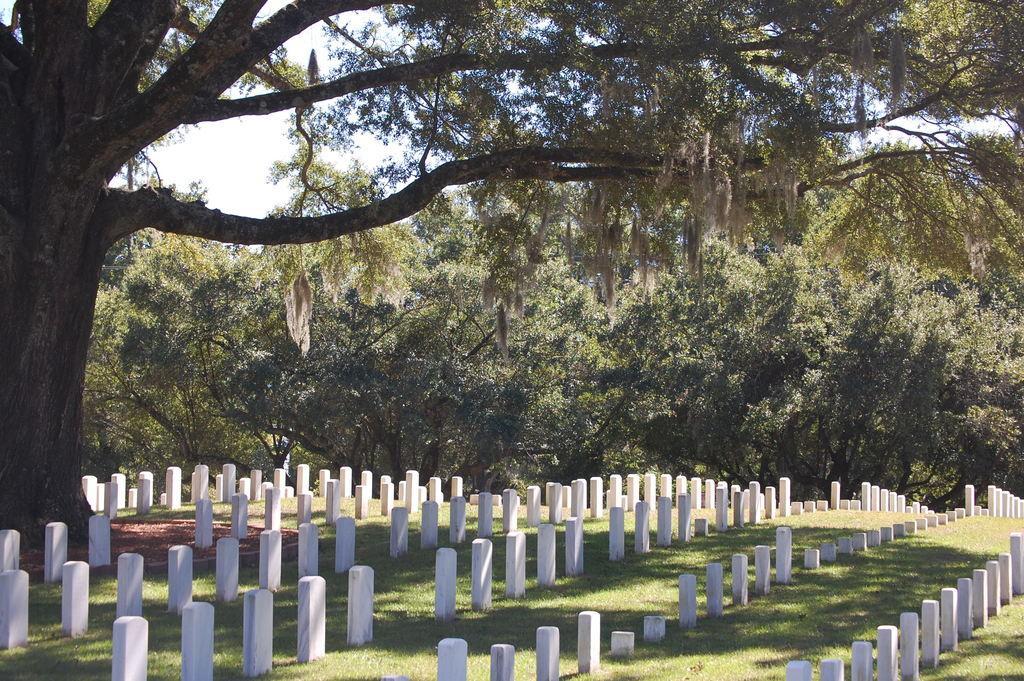Could you give a brief overview of what you see in this image? In this image there are many trees, some grass is there on the surface. Many stones are there, At the top there is the sky. 